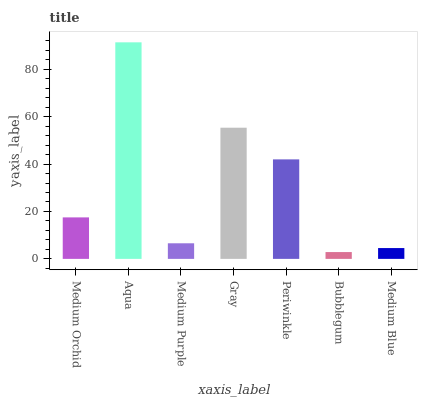Is Bubblegum the minimum?
Answer yes or no. Yes. Is Aqua the maximum?
Answer yes or no. Yes. Is Medium Purple the minimum?
Answer yes or no. No. Is Medium Purple the maximum?
Answer yes or no. No. Is Aqua greater than Medium Purple?
Answer yes or no. Yes. Is Medium Purple less than Aqua?
Answer yes or no. Yes. Is Medium Purple greater than Aqua?
Answer yes or no. No. Is Aqua less than Medium Purple?
Answer yes or no. No. Is Medium Orchid the high median?
Answer yes or no. Yes. Is Medium Orchid the low median?
Answer yes or no. Yes. Is Medium Purple the high median?
Answer yes or no. No. Is Periwinkle the low median?
Answer yes or no. No. 